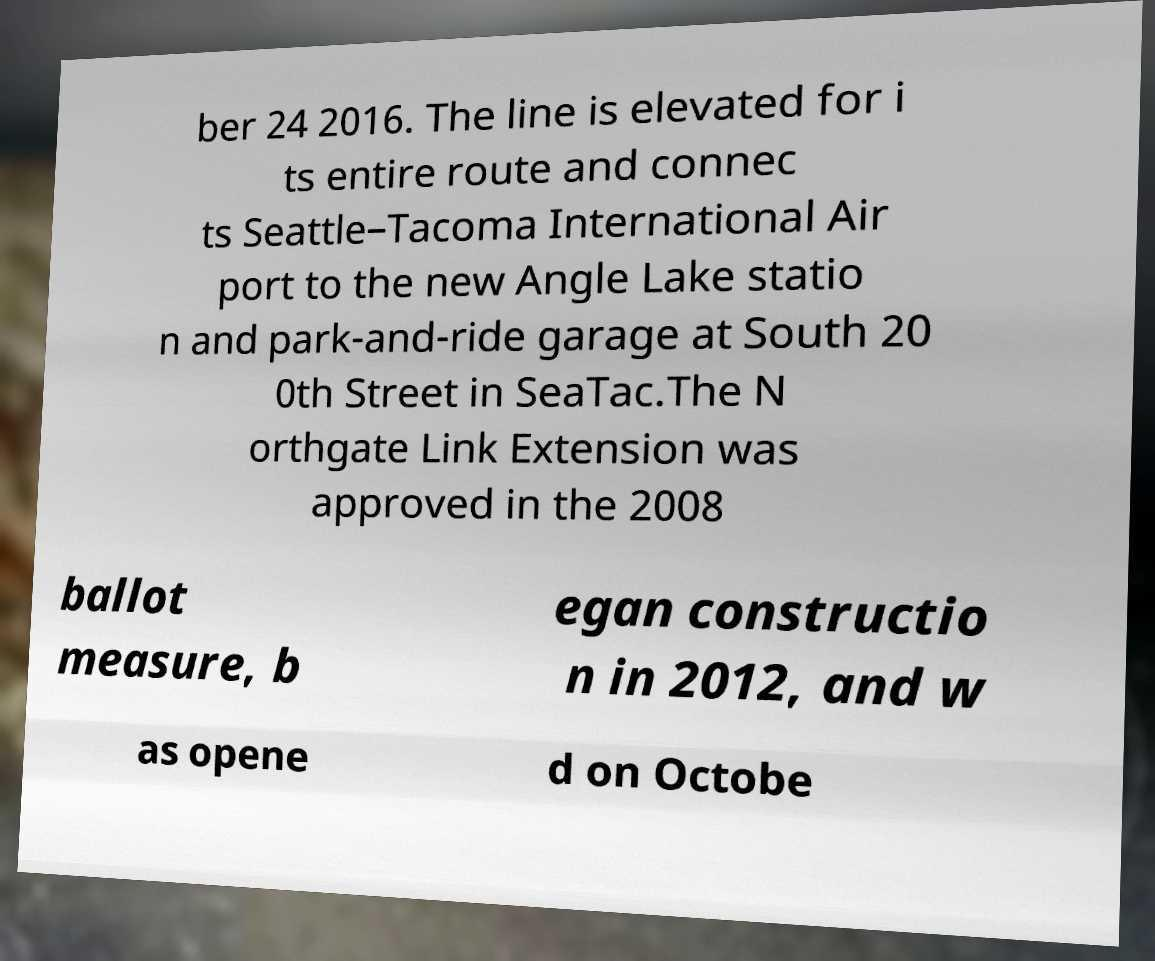What messages or text are displayed in this image? I need them in a readable, typed format. ber 24 2016. The line is elevated for i ts entire route and connec ts Seattle–Tacoma International Air port to the new Angle Lake statio n and park-and-ride garage at South 20 0th Street in SeaTac.The N orthgate Link Extension was approved in the 2008 ballot measure, b egan constructio n in 2012, and w as opene d on Octobe 